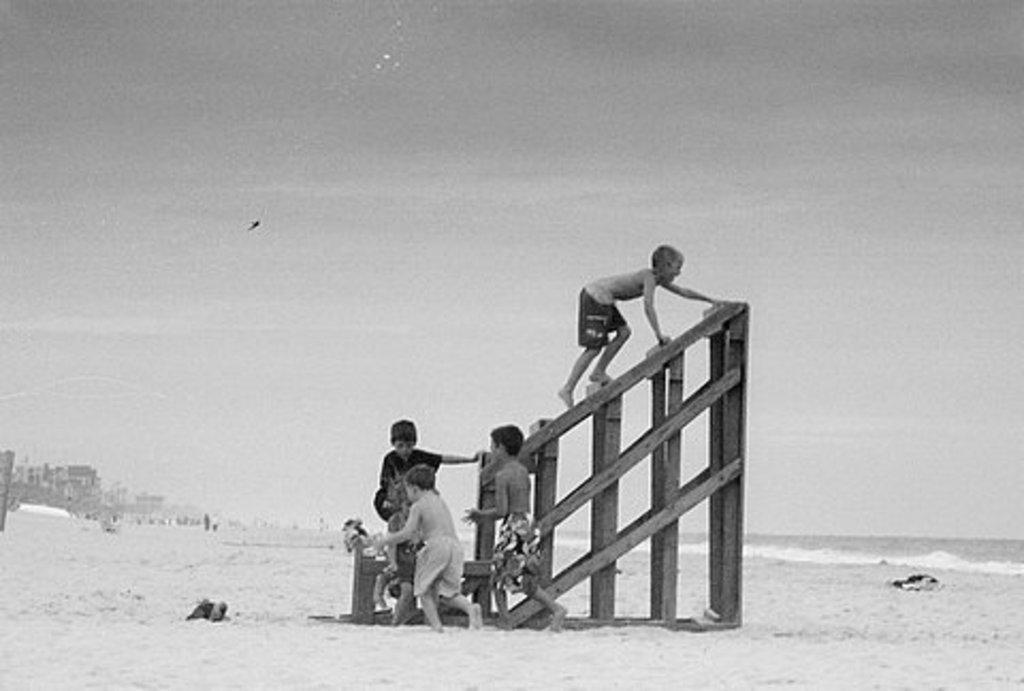How would you summarize this image in a sentence or two? In this image in the center there are persons playing, there is a wooden stand. In the background there are buildings and there is water and there is a bird flying in the sky. In the center there are objects on the ground and at the top we can see sky. 